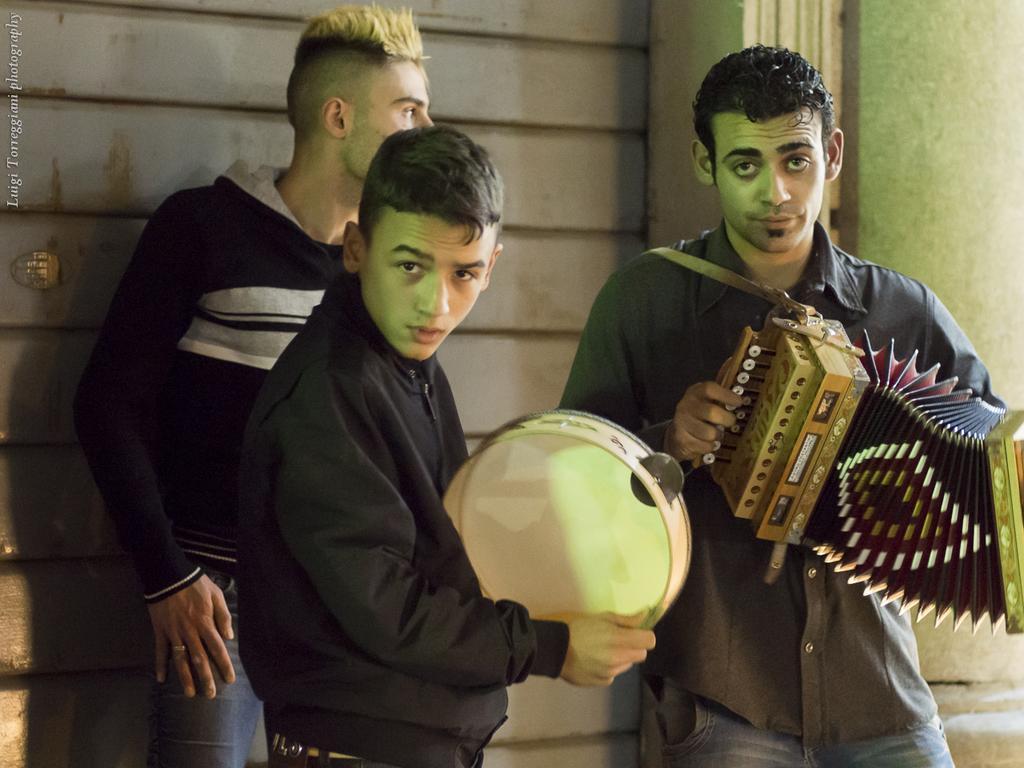Describe this image in one or two sentences. In this picture we can see three men are standing, a man in the front is holding a drum, a man on the right side is holding a musical instrument, in the background there is a wall, we can see some text at the left top of the picture. 